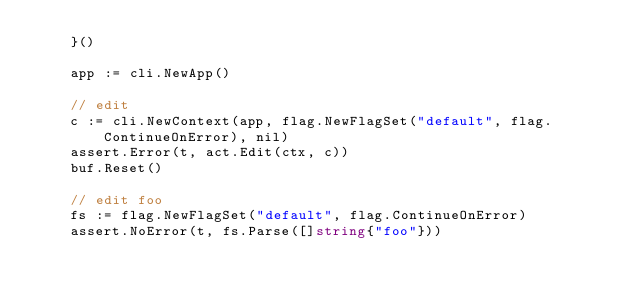Convert code to text. <code><loc_0><loc_0><loc_500><loc_500><_Go_>	}()

	app := cli.NewApp()

	// edit
	c := cli.NewContext(app, flag.NewFlagSet("default", flag.ContinueOnError), nil)
	assert.Error(t, act.Edit(ctx, c))
	buf.Reset()

	// edit foo
	fs := flag.NewFlagSet("default", flag.ContinueOnError)
	assert.NoError(t, fs.Parse([]string{"foo"}))</code> 